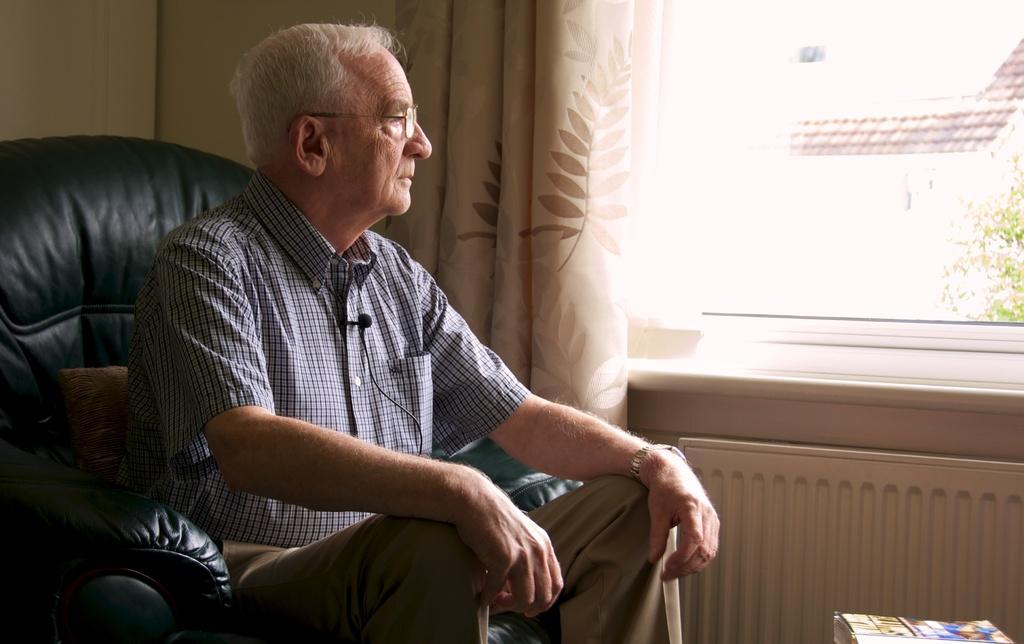Describe this image in one or two sentences. In this picture we can observe a person sitting in the black color sofa. He is wearing a shirt. We can observe a mic fixed to his shirt. He is wearing spectacles. We can observe a curtain and a window. On the right side there is a tree. 